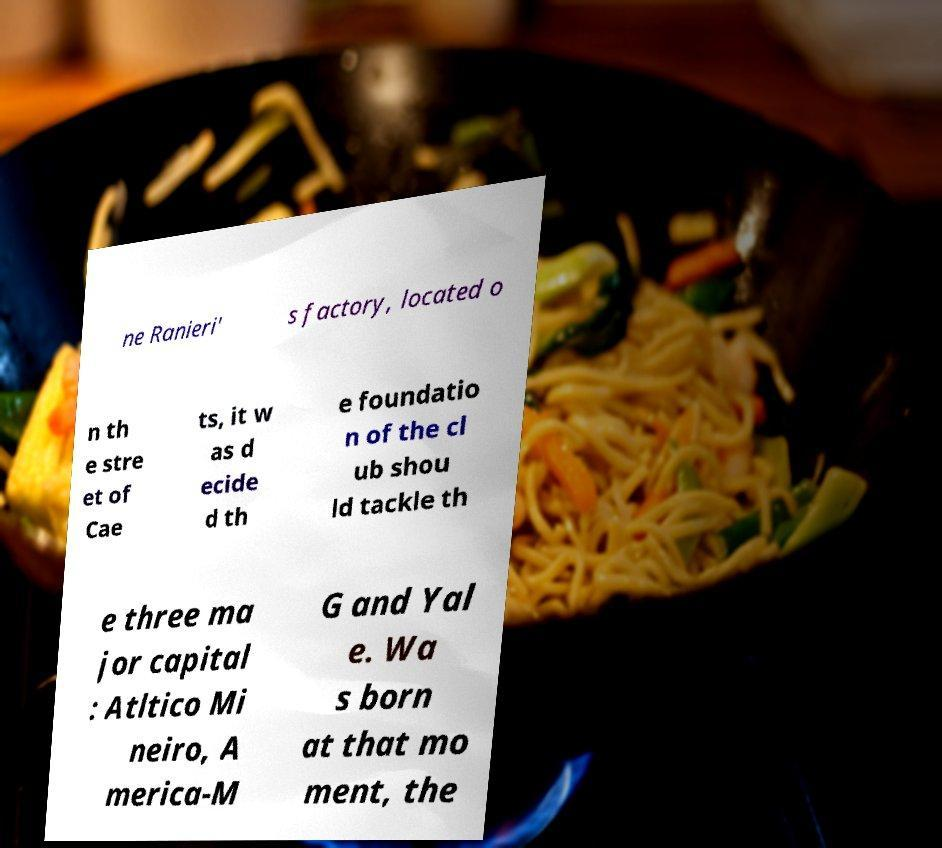I need the written content from this picture converted into text. Can you do that? ne Ranieri' s factory, located o n th e stre et of Cae ts, it w as d ecide d th e foundatio n of the cl ub shou ld tackle th e three ma jor capital : Atltico Mi neiro, A merica-M G and Yal e. Wa s born at that mo ment, the 